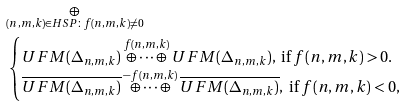<formula> <loc_0><loc_0><loc_500><loc_500>& \underset { ( n , m , k ) \in H S P \colon f ( n , m , k ) \neq 0 } { \oplus } \\ & \begin{cases} U F M ( \Delta _ { n , m , k } ) \overset { f ( n , m , k ) } { \oplus \dots \oplus } U F M ( \Delta _ { n , m , k } ) , \text { if } f ( n , m , k ) > 0 . \\ \overline { U F M ( \Delta _ { n , m , k } ) } \overset { - f ( n , m , k ) } { \oplus \dots \oplus } \overline { U F M ( \Delta _ { n , m , k } ) } , \text { if } f ( n , m , k ) < 0 , \\ \end{cases}</formula> 